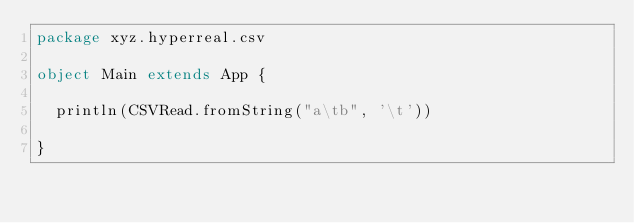Convert code to text. <code><loc_0><loc_0><loc_500><loc_500><_Scala_>package xyz.hyperreal.csv

object Main extends App {

  println(CSVRead.fromString("a\tb", '\t'))

}</code> 